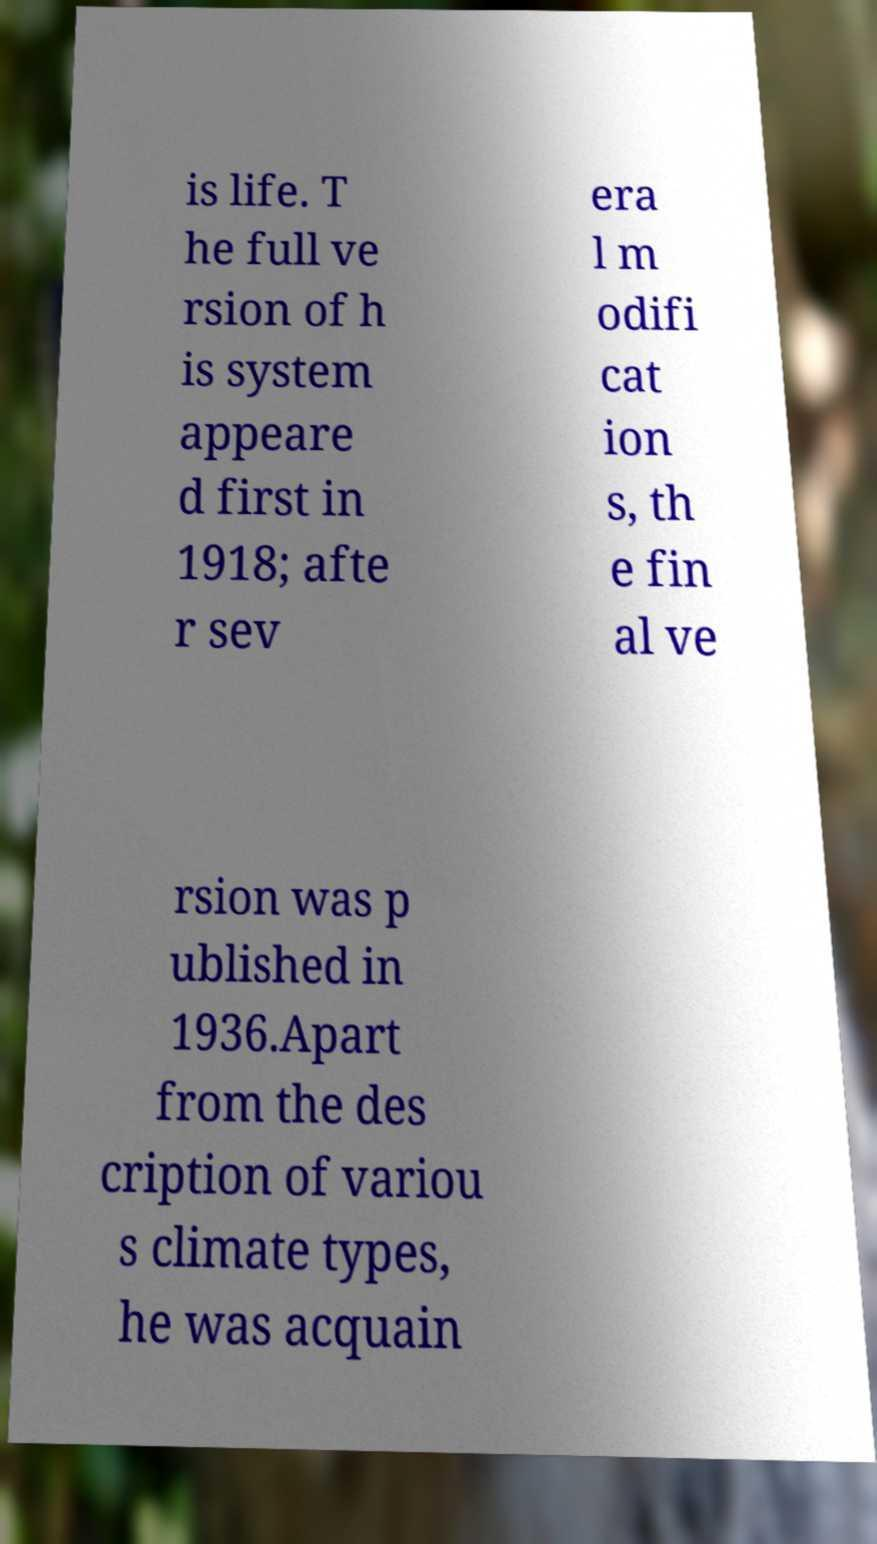I need the written content from this picture converted into text. Can you do that? is life. T he full ve rsion of h is system appeare d first in 1918; afte r sev era l m odifi cat ion s, th e fin al ve rsion was p ublished in 1936.Apart from the des cription of variou s climate types, he was acquain 